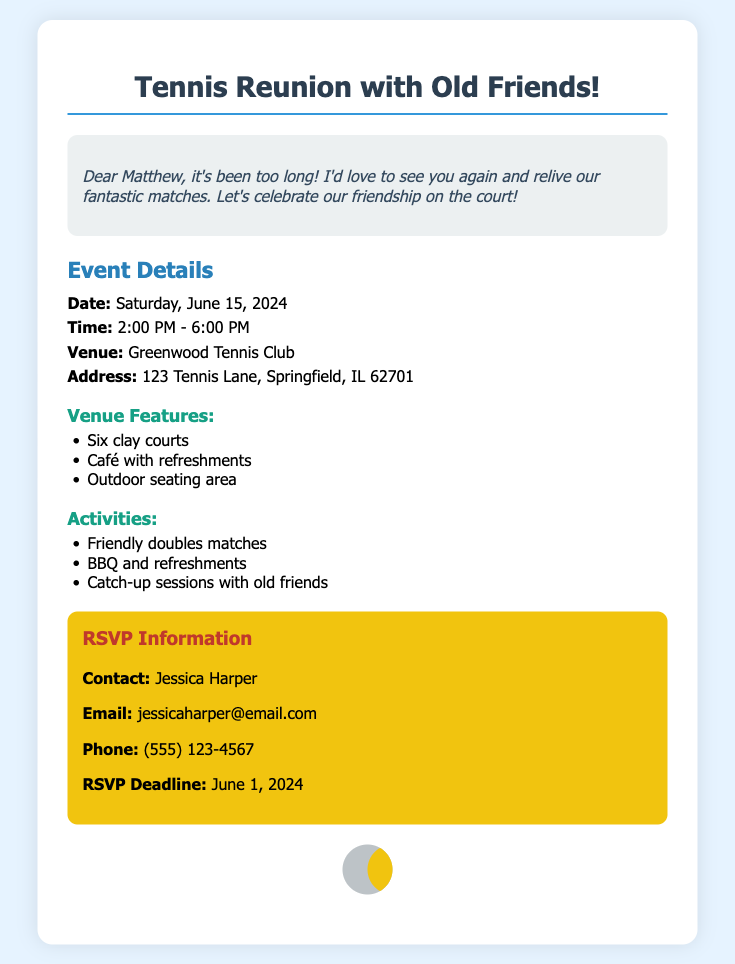What is the date of the event? The date of the event is mentioned clearly in the document as June 15, 2024.
Answer: June 15, 2024 What time does the event start? The starting time of the event is specified in the document as 2:00 PM.
Answer: 2:00 PM Where is the venue located? The document provides the address for the venue as 123 Tennis Lane, Springfield, IL 62701.
Answer: 123 Tennis Lane, Springfield, IL 62701 Who should be contacted for RSVP? The document states that Jessica Harper should be contacted for RSVP information.
Answer: Jessica Harper What is included in the activities? The document lists friendly doubles matches, BBQ, and catch-up sessions as part of the activities.
Answer: Friendly doubles matches, BBQ and refreshments, Catch-up sessions with old friends How many courts are at the venue? The document specifies that there are six clay courts at the venue.
Answer: Six clay courts What is the RSVP deadline? The deadline for RSVPs is mentioned in the document as June 1, 2024.
Answer: June 1, 2024 What is the email address for RSVP? The email address for RSVP is provided in the document as jessicaharper@email.com.
Answer: jessicaharper@email.com What type of event is being organized? The event is described in the document as a Tennis Reunion.
Answer: Tennis Reunion 